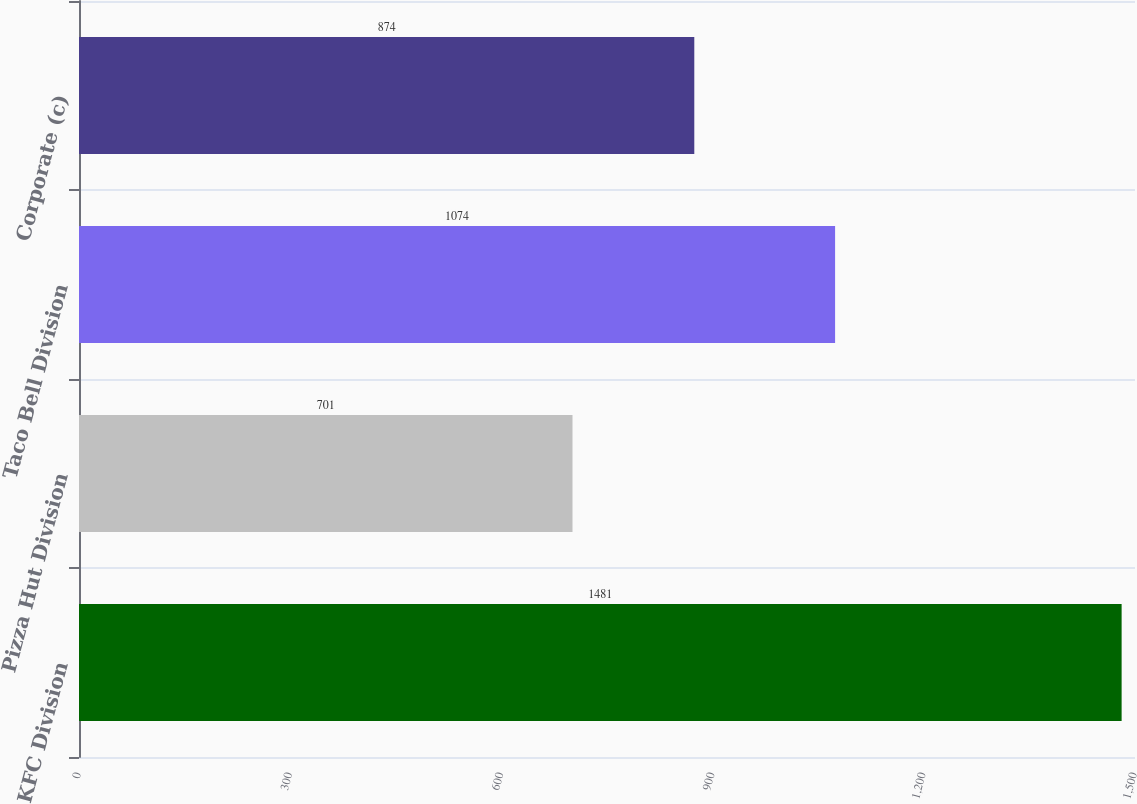<chart> <loc_0><loc_0><loc_500><loc_500><bar_chart><fcel>KFC Division<fcel>Pizza Hut Division<fcel>Taco Bell Division<fcel>Corporate (c)<nl><fcel>1481<fcel>701<fcel>1074<fcel>874<nl></chart> 